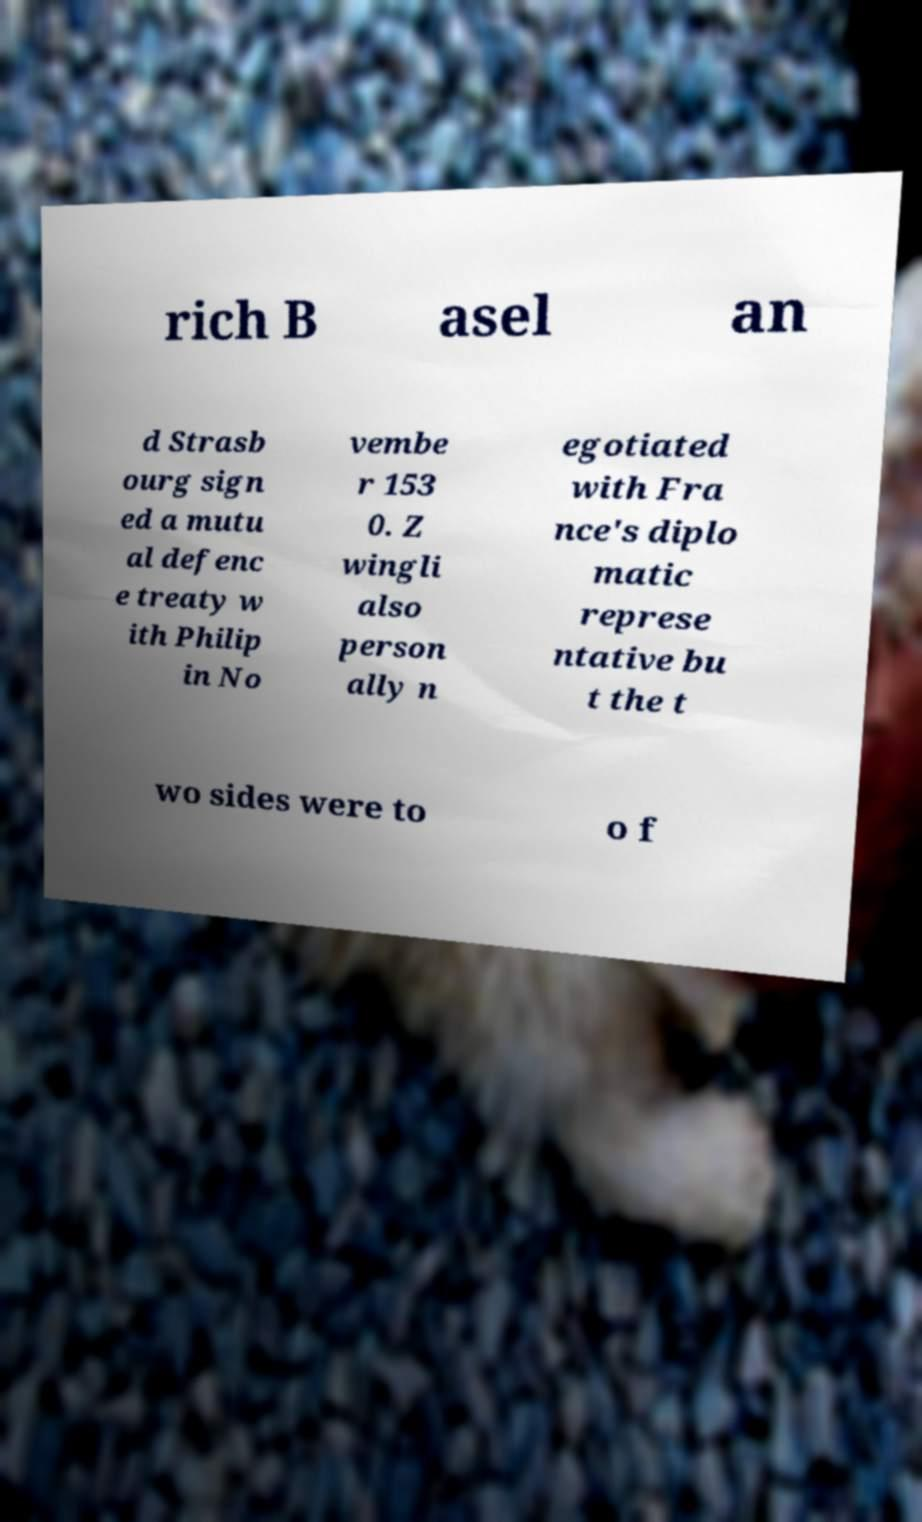I need the written content from this picture converted into text. Can you do that? rich B asel an d Strasb ourg sign ed a mutu al defenc e treaty w ith Philip in No vembe r 153 0. Z wingli also person ally n egotiated with Fra nce's diplo matic represe ntative bu t the t wo sides were to o f 